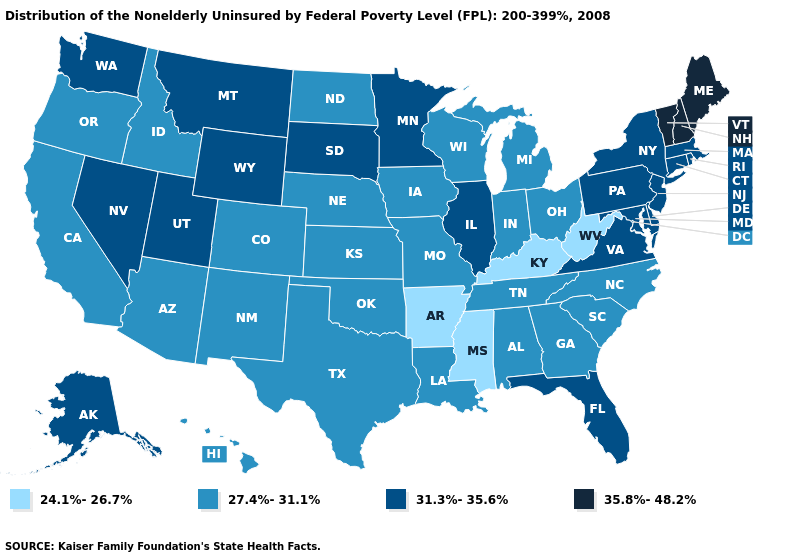Does the first symbol in the legend represent the smallest category?
Quick response, please. Yes. What is the value of Texas?
Concise answer only. 27.4%-31.1%. Does South Dakota have the highest value in the MidWest?
Be succinct. Yes. Does the first symbol in the legend represent the smallest category?
Be succinct. Yes. Does Delaware have the lowest value in the USA?
Short answer required. No. What is the highest value in states that border Florida?
Give a very brief answer. 27.4%-31.1%. Name the states that have a value in the range 35.8%-48.2%?
Short answer required. Maine, New Hampshire, Vermont. What is the highest value in the USA?
Short answer required. 35.8%-48.2%. Name the states that have a value in the range 24.1%-26.7%?
Give a very brief answer. Arkansas, Kentucky, Mississippi, West Virginia. What is the value of Montana?
Be succinct. 31.3%-35.6%. What is the lowest value in the USA?
Concise answer only. 24.1%-26.7%. Which states have the lowest value in the West?
Short answer required. Arizona, California, Colorado, Hawaii, Idaho, New Mexico, Oregon. Does Utah have a lower value than Maine?
Keep it brief. Yes. Does Connecticut have the lowest value in the Northeast?
Keep it brief. Yes. Does Kansas have the highest value in the MidWest?
Answer briefly. No. 